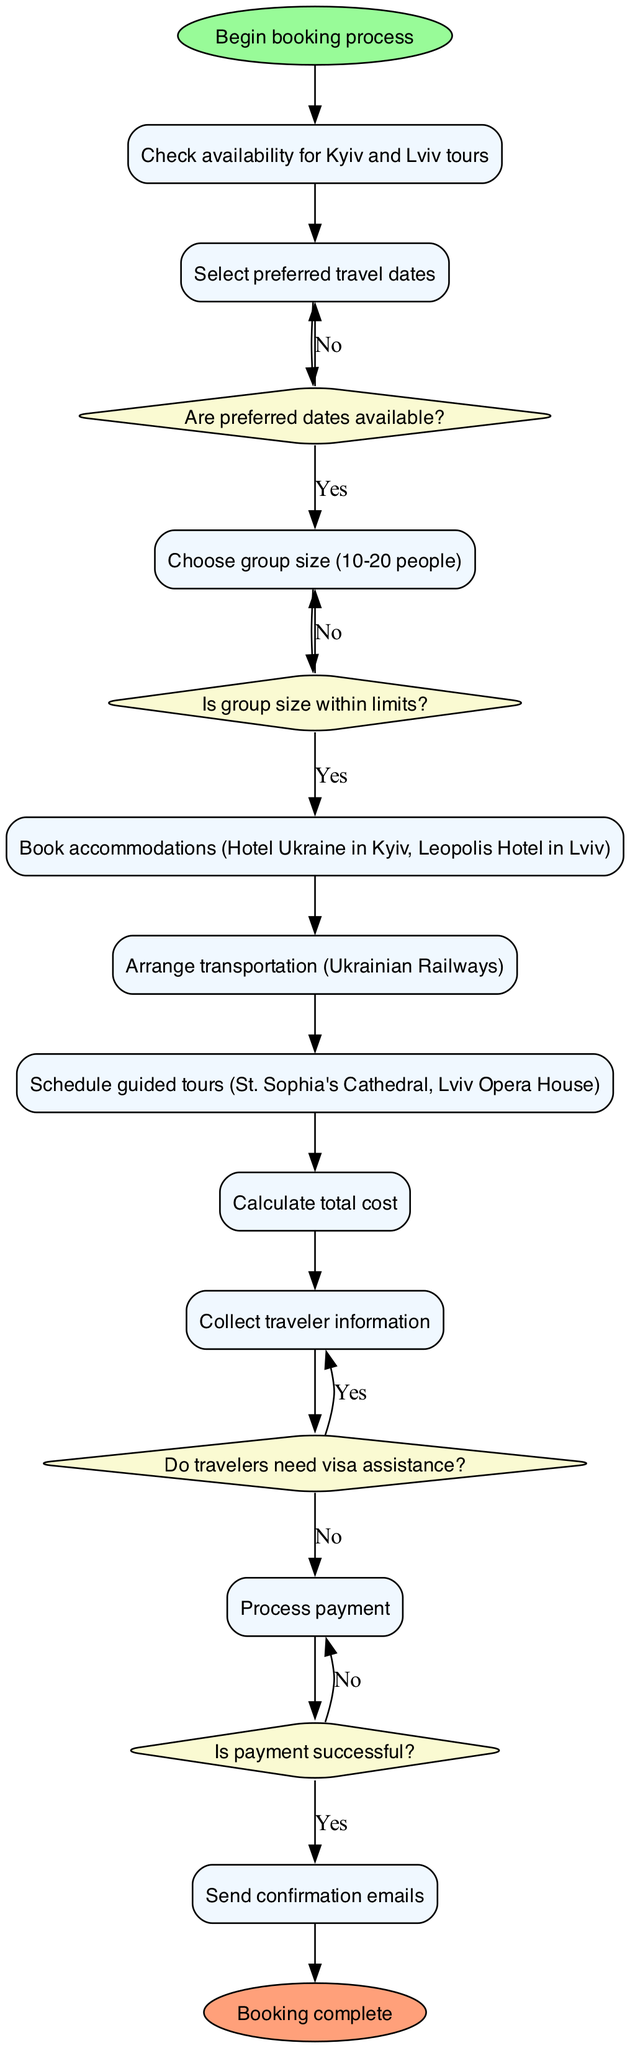What is the starting point of the booking process? The diagram begins with the 'Begin booking process' node, which is the starting point of all actions in the booking process flowchart.
Answer: Begin booking process How many action nodes are there? There are ten action nodes listed in the flowchart representing the steps in the booking process from checking availability to sending confirmation emails.
Answer: 10 What is the last action taken before sending confirmation emails? The last action before sending confirmation emails is 'Process payment', which indicates that all preparations and checks must be completed before the final confirmation step.
Answer: Process payment What happens if the preferred dates for the tour are not available? If the preferred dates are not available, the flowchart shows that it loops back to the action 'Select preferred travel dates', indicating that the process must revisit date selection if availability is an issue.
Answer: Select preferred travel dates Is there a decision point regarding the group size? Yes, there is a decision point labeled 'Is group size within limits?' to determine if the selected group size is acceptable before proceeding to book accommodations.
Answer: Yes What is the next action if visa assistance is needed? If visa assistance is needed, the flowchart indicates that the process continues to the action 'Collect traveler information' without requiring any additional actions or delays.
Answer: Collect traveler information Can the payment fail at any point in the process? Yes, according to the flowchart, there is a decision point 'Is payment successful?' that determines if the process can advance to sending confirmation emails or if it must go back to processing payment again.
Answer: Yes What is the total number of decisions in the flowchart? There are four decision points in the flowchart, each addressing a critical step where a yes or no answer will determine the next action in the booking process.
Answer: 4 What is the final step in the booking process? The final step in the booking process is 'Booking complete', which signifies that all necessary actions have been taken and the booking is finalized.
Answer: Booking complete 